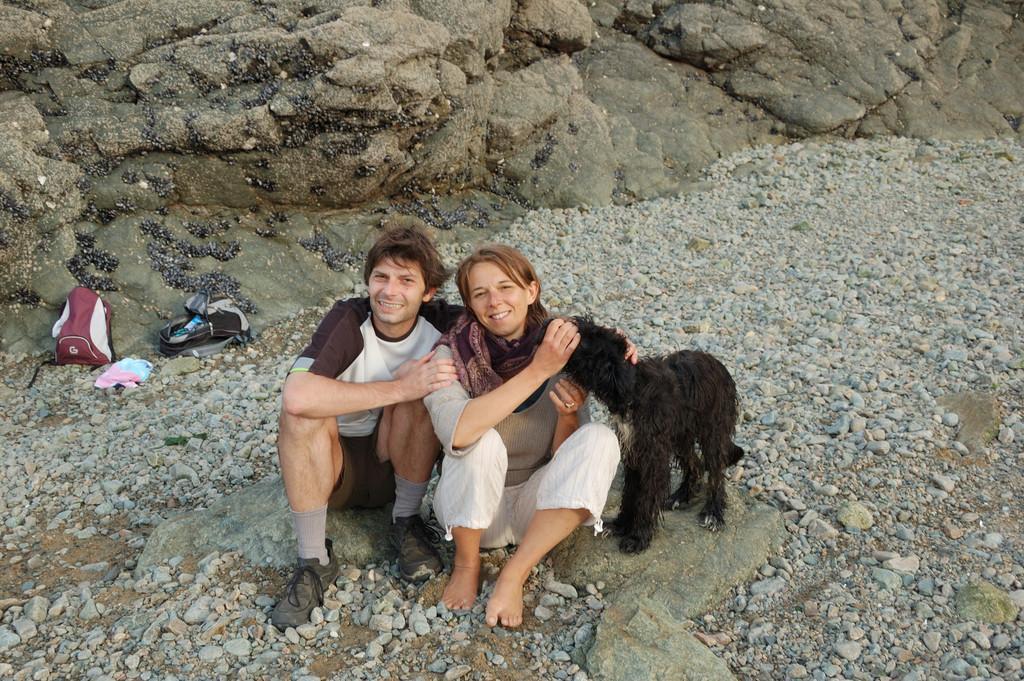Please provide a concise description of this image. In this picture outside of the city. There are two person. They are sitting on a floor. They are smiling. On the right side we have a woman. She is holding a goat. We can see in background rocks and stones. 